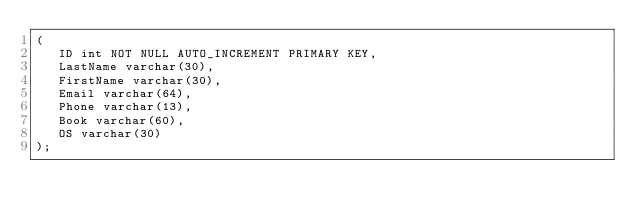<code> <loc_0><loc_0><loc_500><loc_500><_SQL_>(
   ID int NOT NULL AUTO_INCREMENT PRIMARY KEY,
   LastName varchar(30),
   FirstName varchar(30),
   Email varchar(64),
   Phone varchar(13),
   Book varchar(60),
   OS varchar(30)
);


</code> 